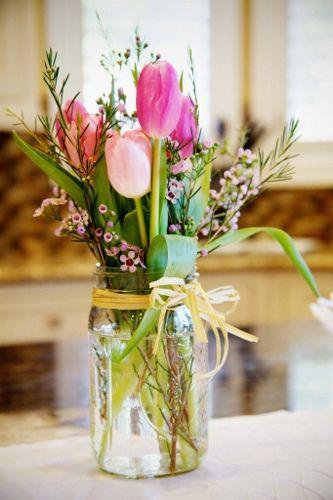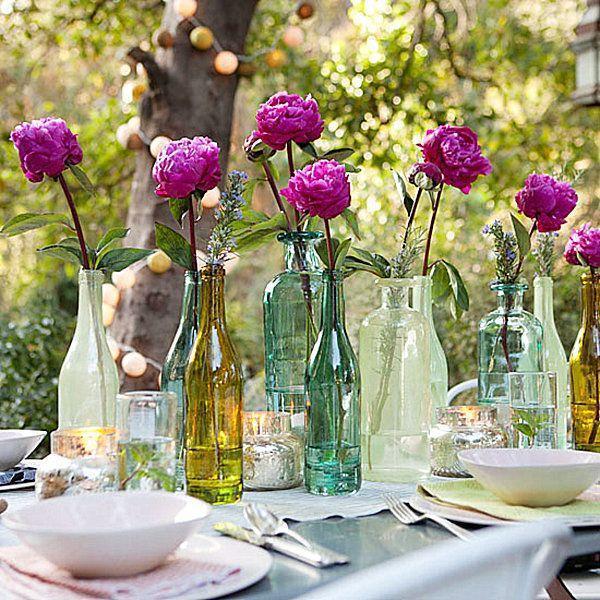The first image is the image on the left, the second image is the image on the right. Examine the images to the left and right. Is the description "Every bottle/vase is on a table and contains at least one flower." accurate? Answer yes or no. Yes. 